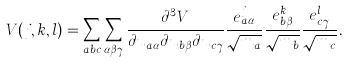<formula> <loc_0><loc_0><loc_500><loc_500>V ( j , k , l ) = \sum _ { a b c } \sum _ { \alpha \beta \gamma } \frac { \partial ^ { 3 } V } { \partial u _ { a \alpha } \partial u _ { b \beta } \partial u _ { c \gamma } } \frac { e ^ { j } _ { a \alpha } } { \sqrt { m _ { a } } } \frac { e ^ { k } _ { b \beta } } { \sqrt { m _ { b } } } \frac { e ^ { l } _ { c \gamma } } { \sqrt { m _ { c } } } .</formula> 